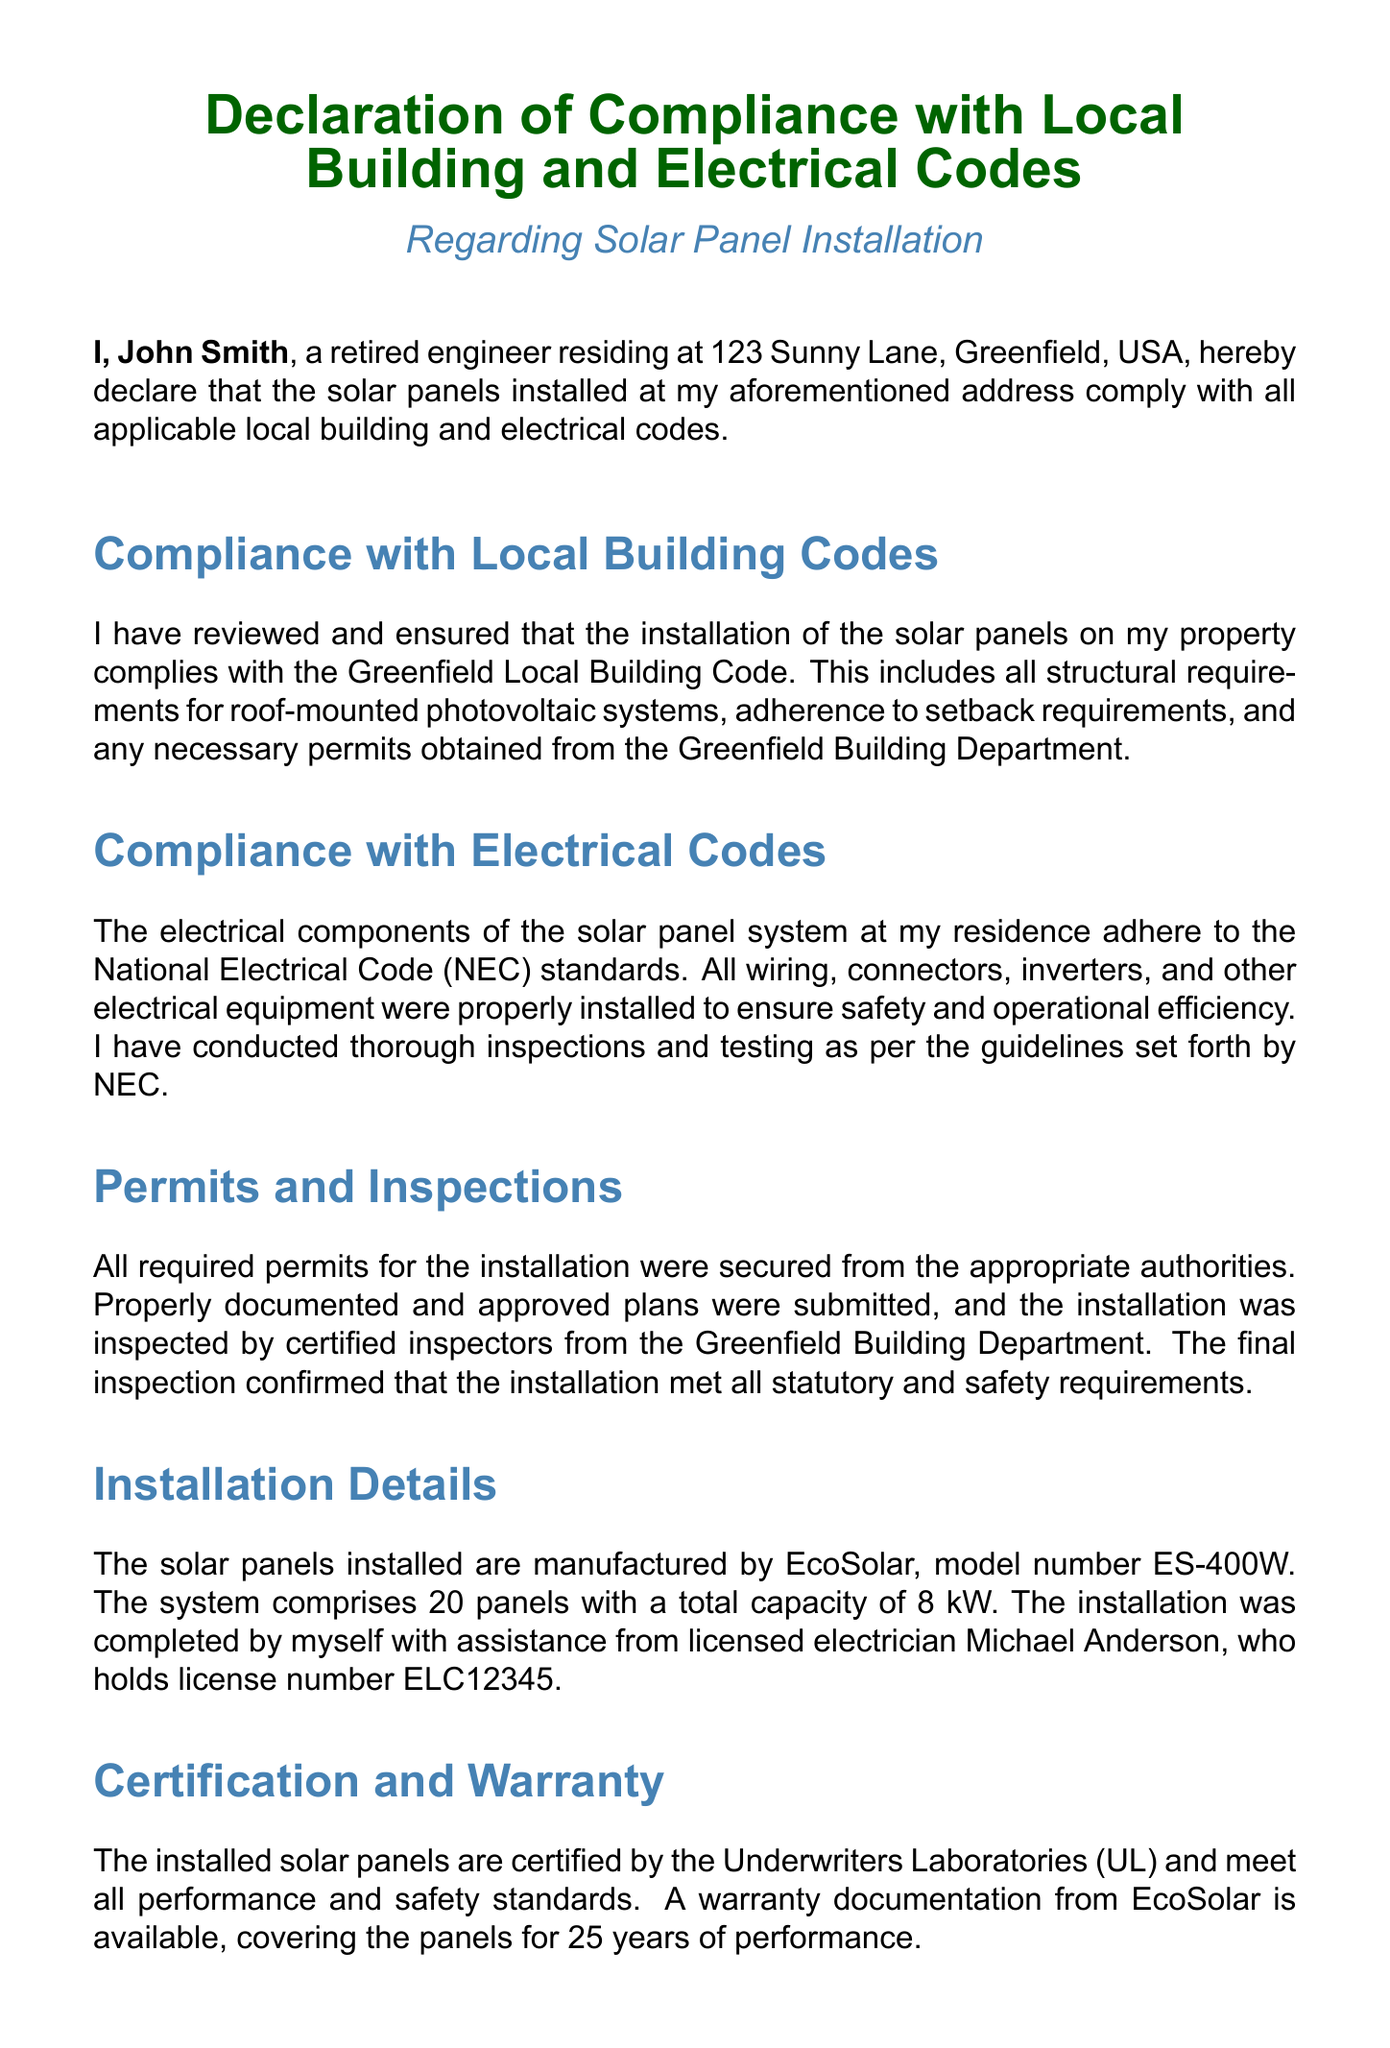What is the address of the declarant? The address is mentioned in the first paragraph, identifying the location of the installation.
Answer: 123 Sunny Lane, Greenfield, USA What is the name of the solar panel manufacturer? The manufacturer's name is specified in the Installation Details section of the document.
Answer: EcoSolar What is the model number of the solar panels? The model number is provided alongside the manufacturer's name in the Installation Details section.
Answer: ES-400W How many solar panels are installed? The total number of panels is stated in the Installation Details section of the document.
Answer: 20 What is the total capacity of the installed solar panel system? The total capacity is mentioned in the installation details, indicating the output capability of the system.
Answer: 8 kW When was the declaration signed? The date of the declaration signing is provided at the end of the document.
Answer: 25th day of October, 2023 Who assisted in the installation of the solar panels? The document names an individual who helped during the installation process.
Answer: Michael Anderson What electrical code do the components adhere to? The applicable electrical code is specified in the Compliance with Electrical Codes section.
Answer: National Electrical Code (NEC) How long is the warranty for the installed solar panels? The length of the warranty is mentioned in the Certification and Warranty section of the document.
Answer: 25 years 